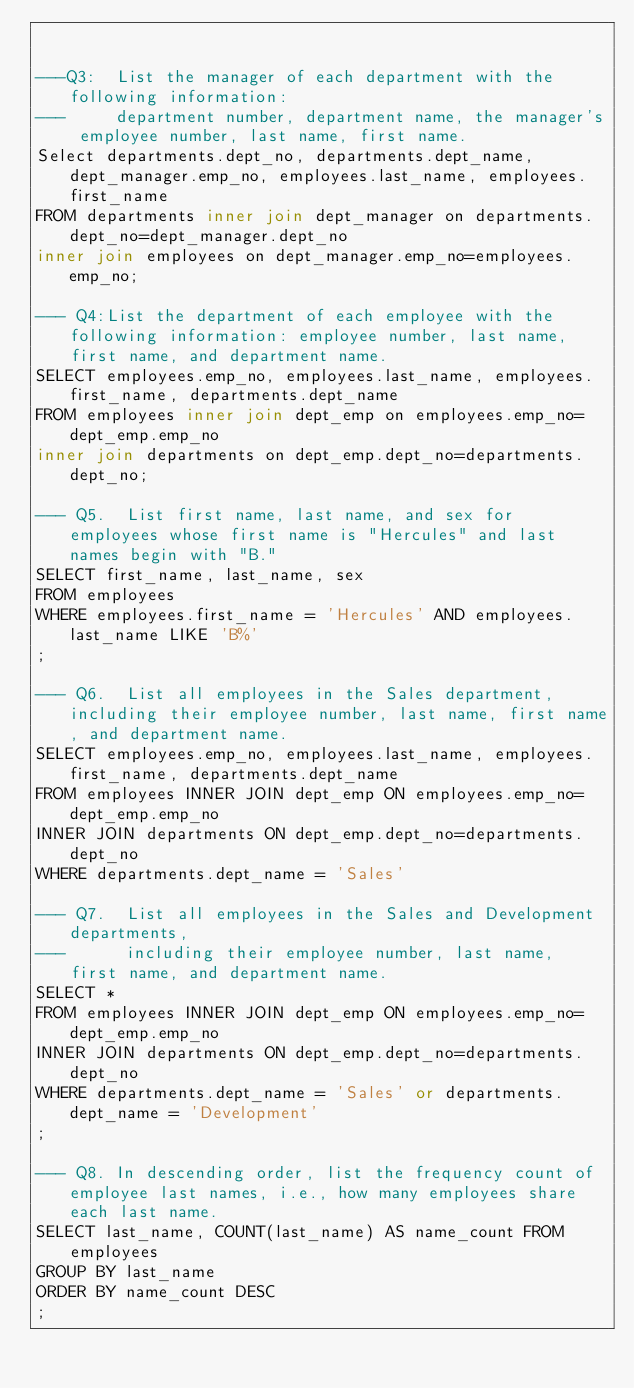<code> <loc_0><loc_0><loc_500><loc_500><_SQL_>

---Q3:  List the manager of each department with the following information: 
---     department number, department name, the manager's employee number, last name, first name.
Select departments.dept_no, departments.dept_name, dept_manager.emp_no, employees.last_name, employees.first_name
FROM departments inner join dept_manager on departments.dept_no=dept_manager.dept_no
inner join employees on dept_manager.emp_no=employees.emp_no;

--- Q4:List the department of each employee with the following information: employee number, last name, first name, and department name.
SELECT employees.emp_no, employees.last_name, employees.first_name, departments.dept_name
FROM employees inner join dept_emp on employees.emp_no=dept_emp.emp_no
inner join departments on dept_emp.dept_no=departments.dept_no;

--- Q5.  List first name, last name, and sex for employees whose first name is "Hercules" and last names begin with "B."
SELECT first_name, last_name, sex
FROM employees
WHERE employees.first_name = 'Hercules' AND employees.last_name LIKE 'B%'
;

--- Q6.  List all employees in the Sales department, including their employee number, last name, first name, and department name.
SELECT employees.emp_no, employees.last_name, employees.first_name, departments.dept_name
FROM employees INNER JOIN dept_emp ON employees.emp_no=dept_emp.emp_no
INNER JOIN departments ON dept_emp.dept_no=departments.dept_no
WHERE departments.dept_name = 'Sales'

--- Q7.  List all employees in the Sales and Development departments, 
---      including their employee number, last name, first name, and department name.
SELECT *
FROM employees INNER JOIN dept_emp ON employees.emp_no=dept_emp.emp_no
INNER JOIN departments ON dept_emp.dept_no=departments.dept_no
WHERE departments.dept_name = 'Sales' or departments.dept_name = 'Development'
;

--- Q8. In descending order, list the frequency count of employee last names, i.e., how many employees share each last name.
SELECT last_name, COUNT(last_name) AS name_count FROM employees
GROUP BY last_name
ORDER BY name_count DESC
;</code> 